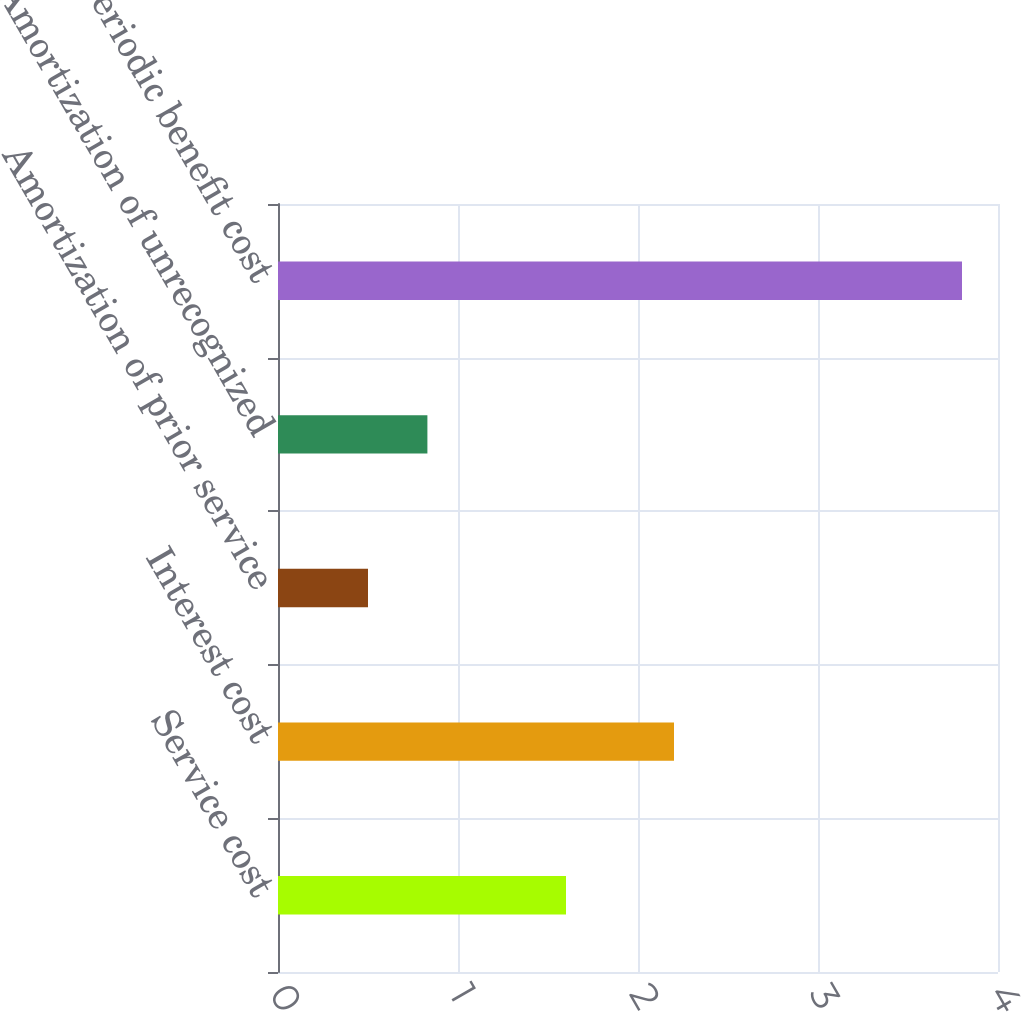Convert chart to OTSL. <chart><loc_0><loc_0><loc_500><loc_500><bar_chart><fcel>Service cost<fcel>Interest cost<fcel>Amortization of prior service<fcel>Amortization of unrecognized<fcel>Net periodic benefit cost<nl><fcel>1.6<fcel>2.2<fcel>0.5<fcel>0.83<fcel>3.8<nl></chart> 